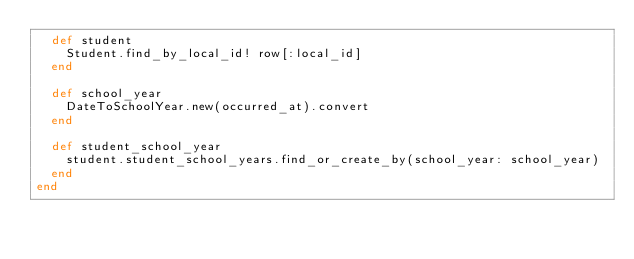<code> <loc_0><loc_0><loc_500><loc_500><_Ruby_>  def student
    Student.find_by_local_id! row[:local_id]
  end

  def school_year
    DateToSchoolYear.new(occurred_at).convert
  end

  def student_school_year
    student.student_school_years.find_or_create_by(school_year: school_year)
  end
end
</code> 